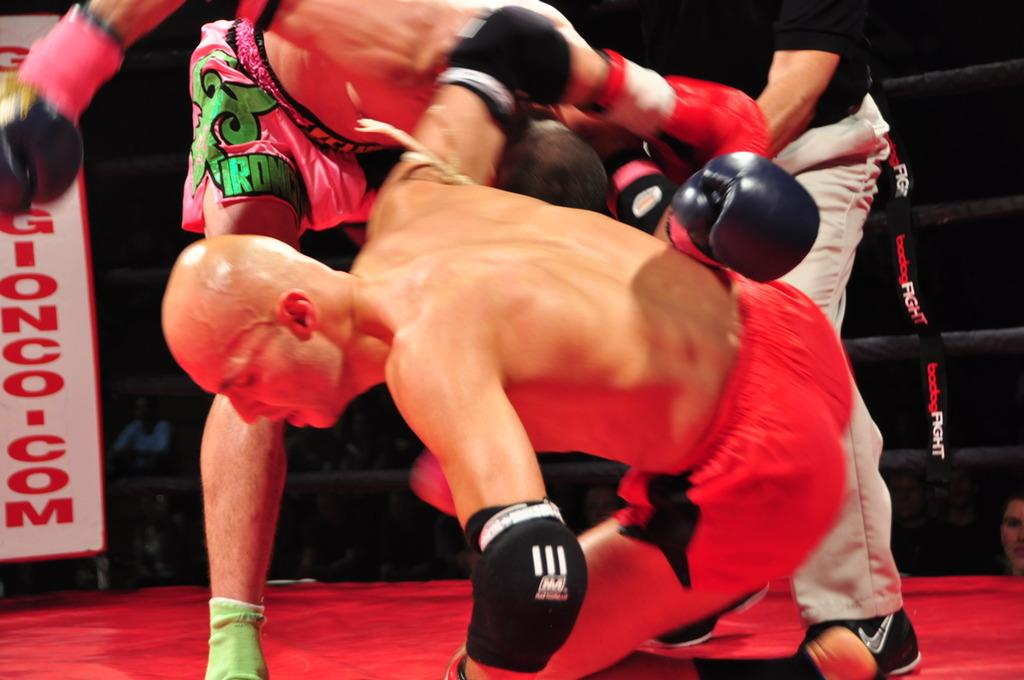What is happening in the boxing ring in the image? There are three people in a boxing ring in the image. What can be seen on the left side of the image? There is a banner on the left side of the image. What is visible in the background of the image? There is a group of people in the background of the image. What type of chalk is being used by the people in the boxing ring? There is no chalk present in the image; it is a boxing scene with people in a ring. 